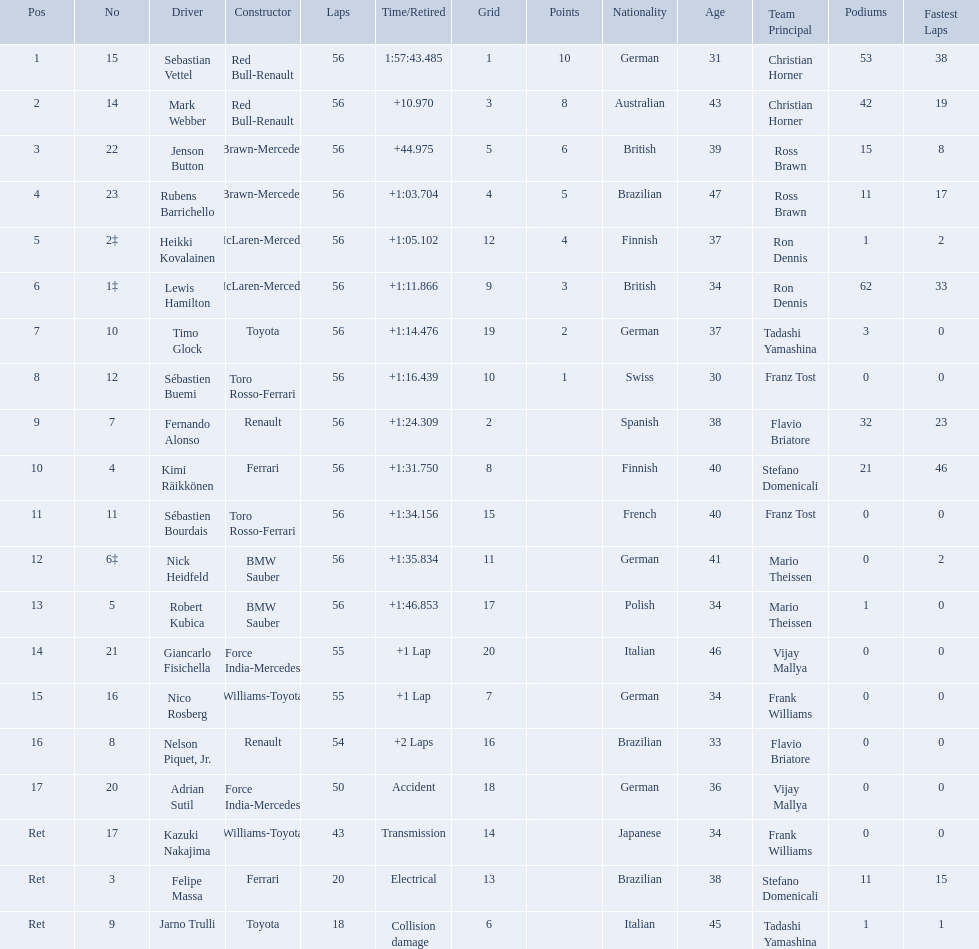Who were all the drivers? Sebastian Vettel, Mark Webber, Jenson Button, Rubens Barrichello, Heikki Kovalainen, Lewis Hamilton, Timo Glock, Sébastien Buemi, Fernando Alonso, Kimi Räikkönen, Sébastien Bourdais, Nick Heidfeld, Robert Kubica, Giancarlo Fisichella, Nico Rosberg, Nelson Piquet, Jr., Adrian Sutil, Kazuki Nakajima, Felipe Massa, Jarno Trulli. Which of these didn't have ferrari as a constructor? Sebastian Vettel, Mark Webber, Jenson Button, Rubens Barrichello, Heikki Kovalainen, Lewis Hamilton, Timo Glock, Sébastien Buemi, Fernando Alonso, Sébastien Bourdais, Nick Heidfeld, Robert Kubica, Giancarlo Fisichella, Nico Rosberg, Nelson Piquet, Jr., Adrian Sutil, Kazuki Nakajima, Jarno Trulli. Which of these was in first place? Sebastian Vettel. Who are all the drivers? Sebastian Vettel, Mark Webber, Jenson Button, Rubens Barrichello, Heikki Kovalainen, Lewis Hamilton, Timo Glock, Sébastien Buemi, Fernando Alonso, Kimi Räikkönen, Sébastien Bourdais, Nick Heidfeld, Robert Kubica, Giancarlo Fisichella, Nico Rosberg, Nelson Piquet, Jr., Adrian Sutil, Kazuki Nakajima, Felipe Massa, Jarno Trulli. What were their finishing times? 1:57:43.485, +10.970, +44.975, +1:03.704, +1:05.102, +1:11.866, +1:14.476, +1:16.439, +1:24.309, +1:31.750, +1:34.156, +1:35.834, +1:46.853, +1 Lap, +1 Lap, +2 Laps, Accident, Transmission, Electrical, Collision damage. Who finished last? Robert Kubica. Who were the drivers at the 2009 chinese grand prix? Sebastian Vettel, Mark Webber, Jenson Button, Rubens Barrichello, Heikki Kovalainen, Lewis Hamilton, Timo Glock, Sébastien Buemi, Fernando Alonso, Kimi Räikkönen, Sébastien Bourdais, Nick Heidfeld, Robert Kubica, Giancarlo Fisichella, Nico Rosberg, Nelson Piquet, Jr., Adrian Sutil, Kazuki Nakajima, Felipe Massa, Jarno Trulli. Who had the slowest time? Robert Kubica. Which drive retired because of electrical issues? Felipe Massa. Which driver retired due to accident? Adrian Sutil. Which driver retired due to collision damage? Jarno Trulli. Why did the  toyota retire Collision damage. What was the drivers name? Jarno Trulli. 